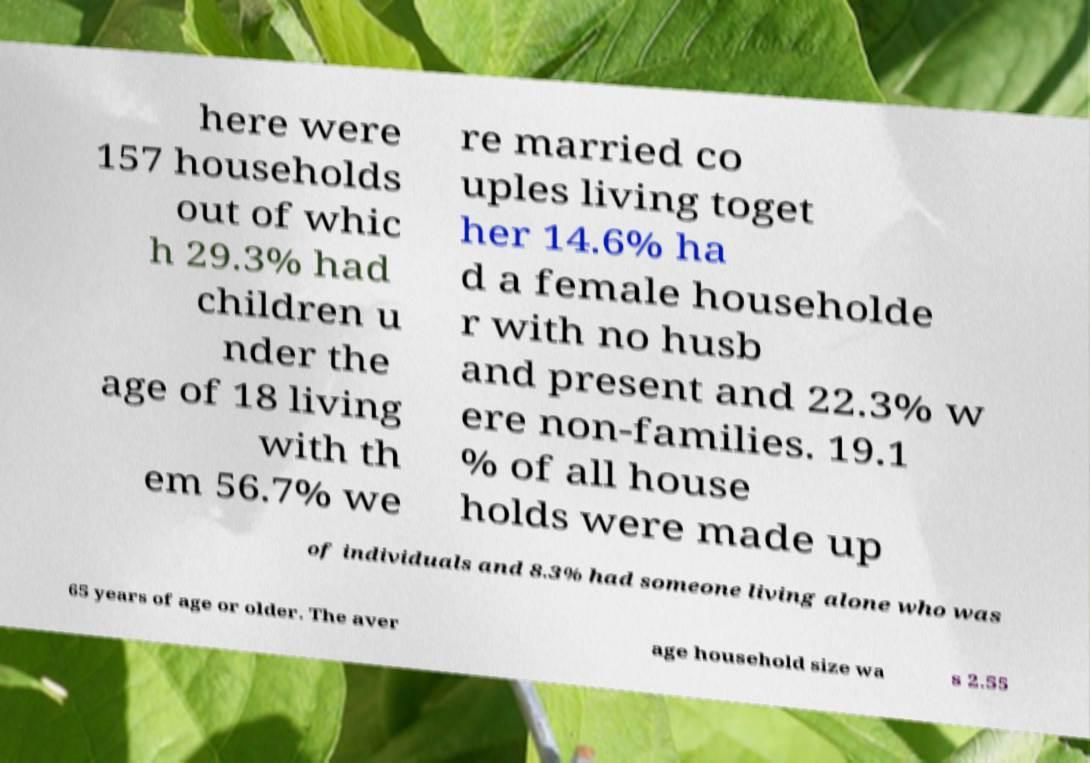Could you extract and type out the text from this image? here were 157 households out of whic h 29.3% had children u nder the age of 18 living with th em 56.7% we re married co uples living toget her 14.6% ha d a female householde r with no husb and present and 22.3% w ere non-families. 19.1 % of all house holds were made up of individuals and 8.3% had someone living alone who was 65 years of age or older. The aver age household size wa s 2.55 